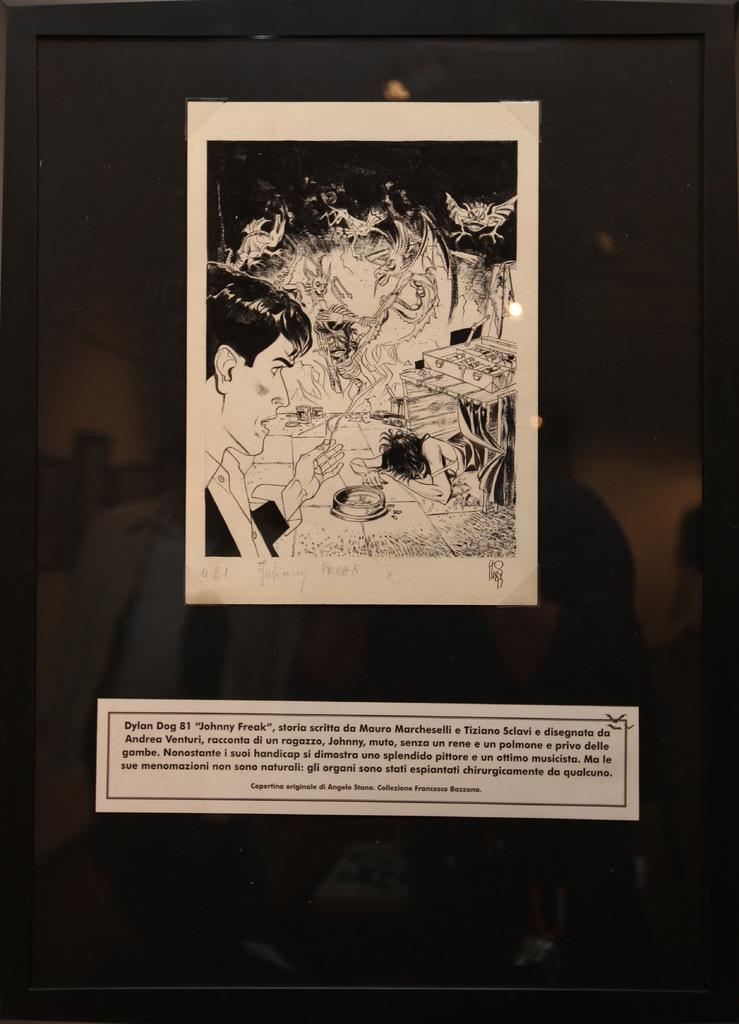<image>
Relay a brief, clear account of the picture shown. A picture that has Johnny Freak written under the picture. 